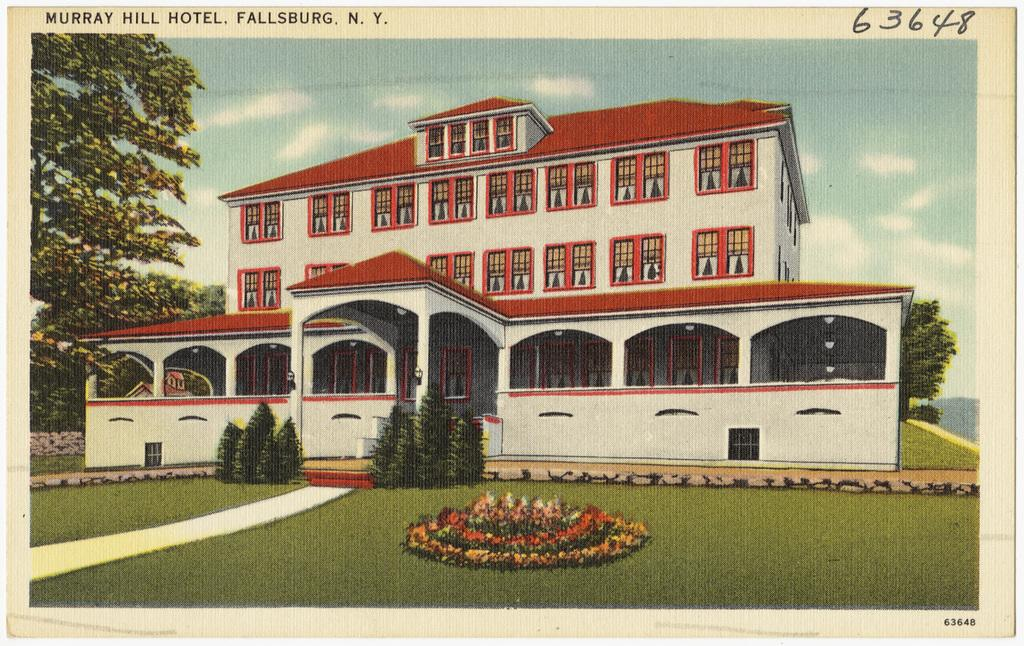What is the main subject of the image? The main subject of the image is a photo of a building. What other elements can be seen in the image besides the building? There are plants, trees, the ground, a path, the sky, clouds, text, and numbers present in the image. Can you describe the natural elements in the image? The natural elements in the image include plants, trees, and the sky with clouds. What type of man-made structure is visible in the image? The man-made structure visible in the image is a path. What is the purpose of the text and numbers in the image? The purpose of the text and numbers in the image is not clear from the facts provided. How many grapes are hanging from the trees in the image? There are no grapes visible in the image; only plants and trees are present. What type of pies are being served on the path in the image? There are no pies present in the image; only a path is visible. 